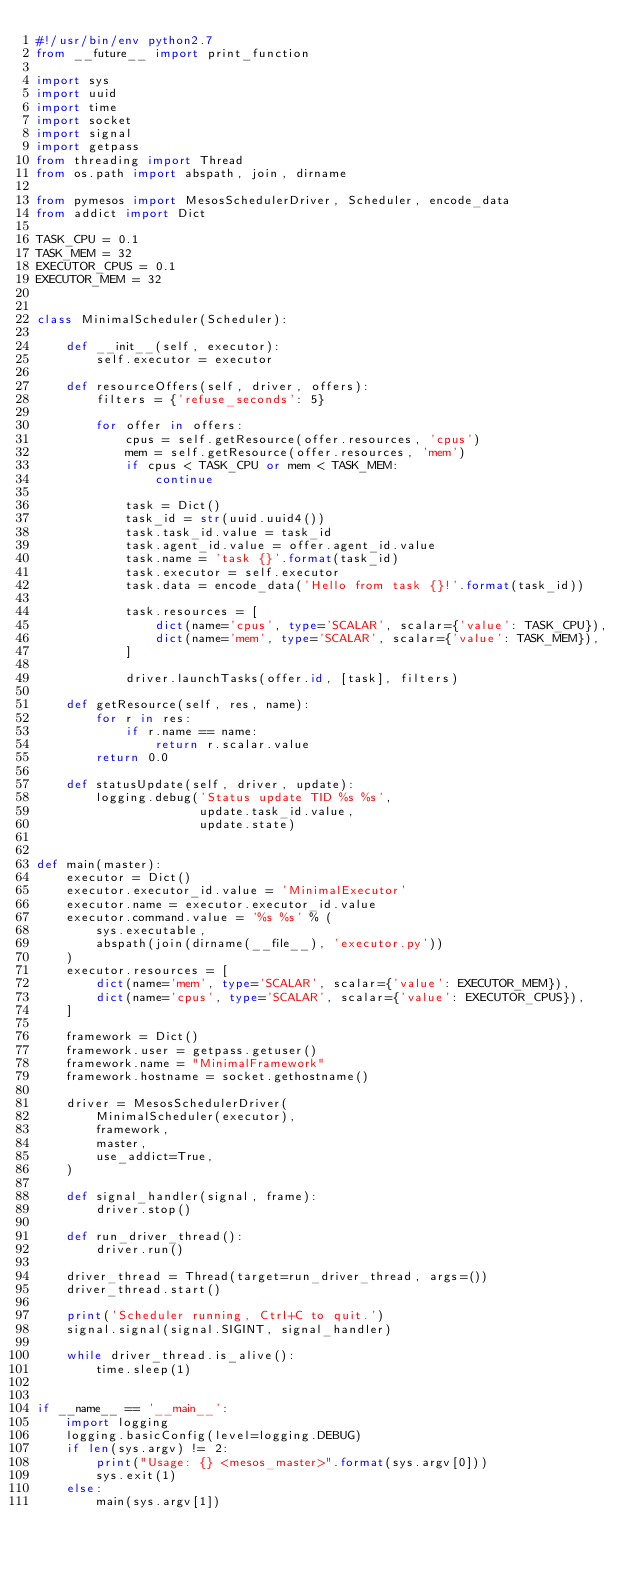<code> <loc_0><loc_0><loc_500><loc_500><_Python_>#!/usr/bin/env python2.7
from __future__ import print_function

import sys
import uuid
import time
import socket
import signal
import getpass
from threading import Thread
from os.path import abspath, join, dirname

from pymesos import MesosSchedulerDriver, Scheduler, encode_data
from addict import Dict

TASK_CPU = 0.1
TASK_MEM = 32
EXECUTOR_CPUS = 0.1
EXECUTOR_MEM = 32


class MinimalScheduler(Scheduler):

    def __init__(self, executor):
        self.executor = executor

    def resourceOffers(self, driver, offers):
        filters = {'refuse_seconds': 5}

        for offer in offers:
            cpus = self.getResource(offer.resources, 'cpus')
            mem = self.getResource(offer.resources, 'mem')
            if cpus < TASK_CPU or mem < TASK_MEM:
                continue

            task = Dict()
            task_id = str(uuid.uuid4())
            task.task_id.value = task_id
            task.agent_id.value = offer.agent_id.value
            task.name = 'task {}'.format(task_id)
            task.executor = self.executor
            task.data = encode_data('Hello from task {}!'.format(task_id))

            task.resources = [
                dict(name='cpus', type='SCALAR', scalar={'value': TASK_CPU}),
                dict(name='mem', type='SCALAR', scalar={'value': TASK_MEM}),
            ]

            driver.launchTasks(offer.id, [task], filters)

    def getResource(self, res, name):
        for r in res:
            if r.name == name:
                return r.scalar.value
        return 0.0

    def statusUpdate(self, driver, update):
        logging.debug('Status update TID %s %s',
                      update.task_id.value,
                      update.state)


def main(master):
    executor = Dict()
    executor.executor_id.value = 'MinimalExecutor'
    executor.name = executor.executor_id.value
    executor.command.value = '%s %s' % (
        sys.executable,
        abspath(join(dirname(__file__), 'executor.py'))
    )
    executor.resources = [
        dict(name='mem', type='SCALAR', scalar={'value': EXECUTOR_MEM}),
        dict(name='cpus', type='SCALAR', scalar={'value': EXECUTOR_CPUS}),
    ]

    framework = Dict()
    framework.user = getpass.getuser()
    framework.name = "MinimalFramework"
    framework.hostname = socket.gethostname()

    driver = MesosSchedulerDriver(
        MinimalScheduler(executor),
        framework,
        master,
        use_addict=True,
    )

    def signal_handler(signal, frame):
        driver.stop()

    def run_driver_thread():
        driver.run()

    driver_thread = Thread(target=run_driver_thread, args=())
    driver_thread.start()

    print('Scheduler running, Ctrl+C to quit.')
    signal.signal(signal.SIGINT, signal_handler)

    while driver_thread.is_alive():
        time.sleep(1)


if __name__ == '__main__':
    import logging
    logging.basicConfig(level=logging.DEBUG)
    if len(sys.argv) != 2:
        print("Usage: {} <mesos_master>".format(sys.argv[0]))
        sys.exit(1)
    else:
        main(sys.argv[1])
</code> 